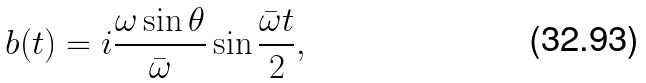Convert formula to latex. <formula><loc_0><loc_0><loc_500><loc_500>b ( t ) = i \frac { \omega \sin { \theta } } { \bar { \omega } } \sin { \frac { \bar { \omega } t } { 2 } } ,</formula> 